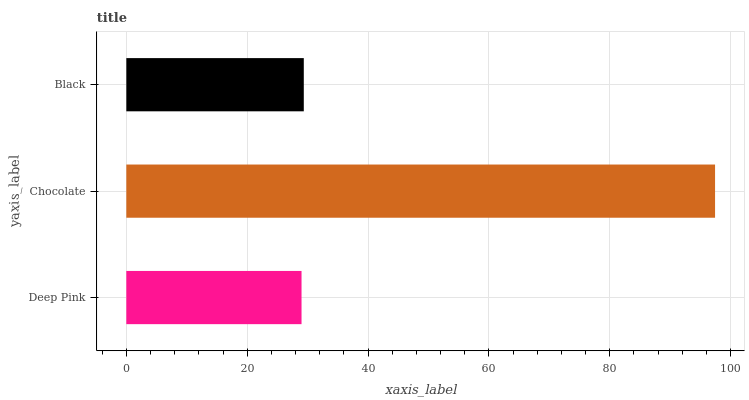Is Deep Pink the minimum?
Answer yes or no. Yes. Is Chocolate the maximum?
Answer yes or no. Yes. Is Black the minimum?
Answer yes or no. No. Is Black the maximum?
Answer yes or no. No. Is Chocolate greater than Black?
Answer yes or no. Yes. Is Black less than Chocolate?
Answer yes or no. Yes. Is Black greater than Chocolate?
Answer yes or no. No. Is Chocolate less than Black?
Answer yes or no. No. Is Black the high median?
Answer yes or no. Yes. Is Black the low median?
Answer yes or no. Yes. Is Chocolate the high median?
Answer yes or no. No. Is Deep Pink the low median?
Answer yes or no. No. 